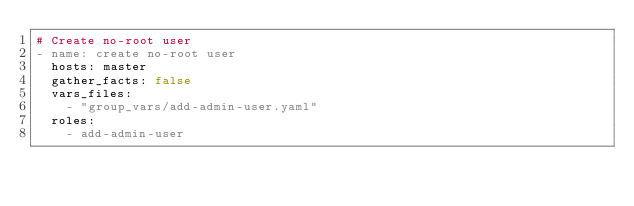Convert code to text. <code><loc_0><loc_0><loc_500><loc_500><_YAML_># Create no-root user
- name: create no-root user
  hosts: master
  gather_facts: false
  vars_files:
    - "group_vars/add-admin-user.yaml"  
  roles:
    - add-admin-user</code> 